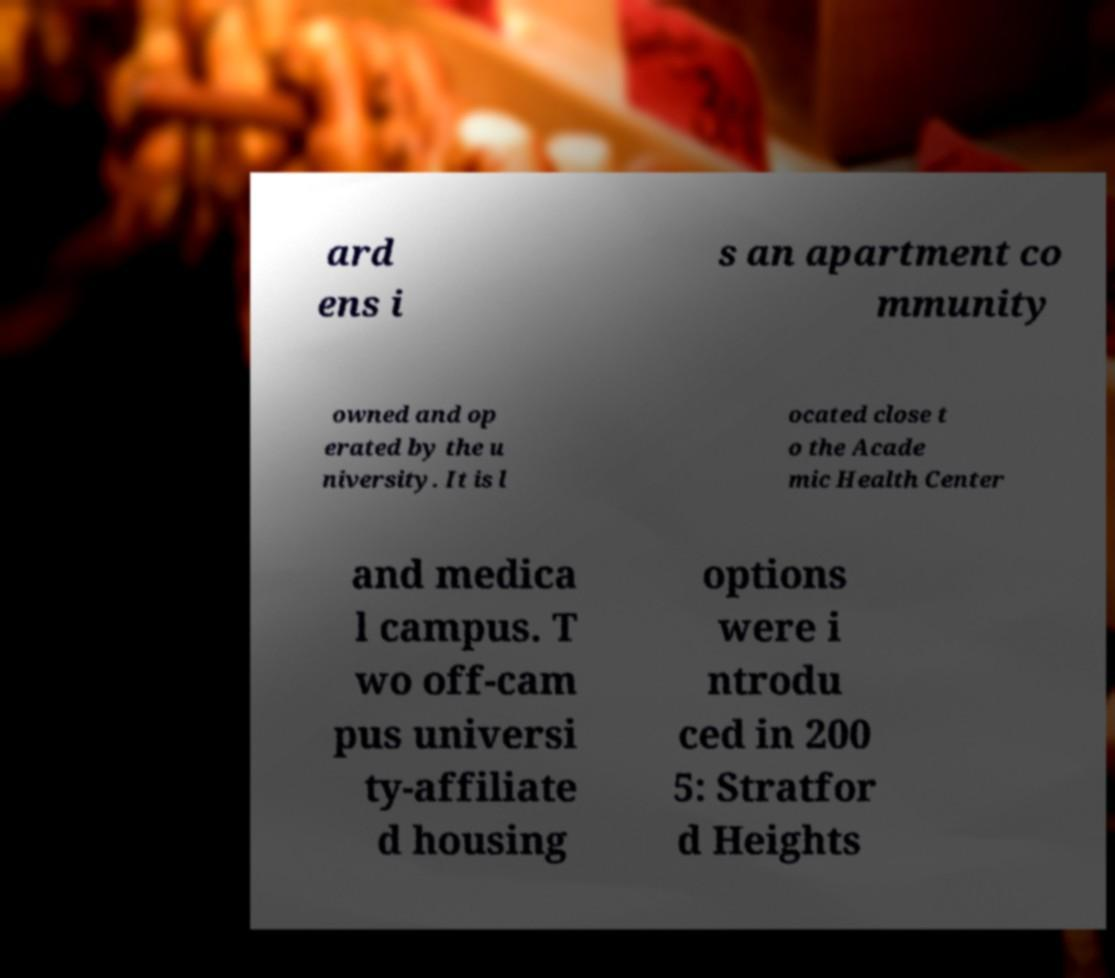Can you read and provide the text displayed in the image?This photo seems to have some interesting text. Can you extract and type it out for me? ard ens i s an apartment co mmunity owned and op erated by the u niversity. It is l ocated close t o the Acade mic Health Center and medica l campus. T wo off-cam pus universi ty-affiliate d housing options were i ntrodu ced in 200 5: Stratfor d Heights 